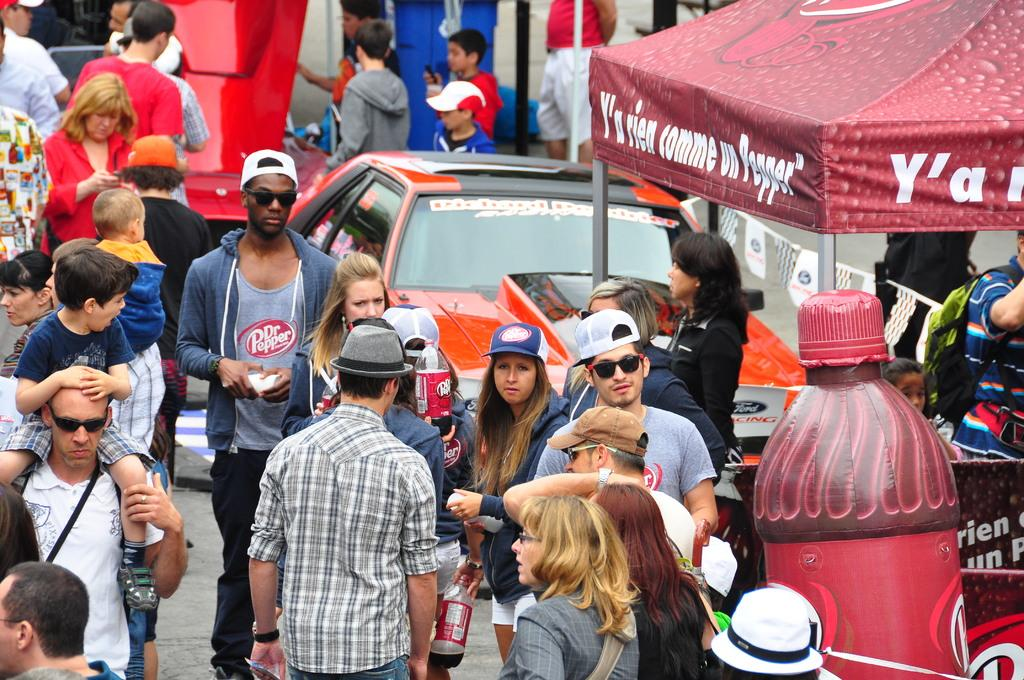What is happening in the image involving a group of people? The people are passing through a street in the image. Are there any vehicles visible in the image? Yes, there is a car in the image. What other objects can be seen in the image? There is a bottle and a tent in the image. What accessories are some people wearing in the image? Some people are wearing hats and sunglasses (shades) in the image. What type of crown can be seen on the head of the person in the image? There is no crown visible on anyone's head in the image. Is there a rifle present in the image? No, there is no rifle present in the image. 